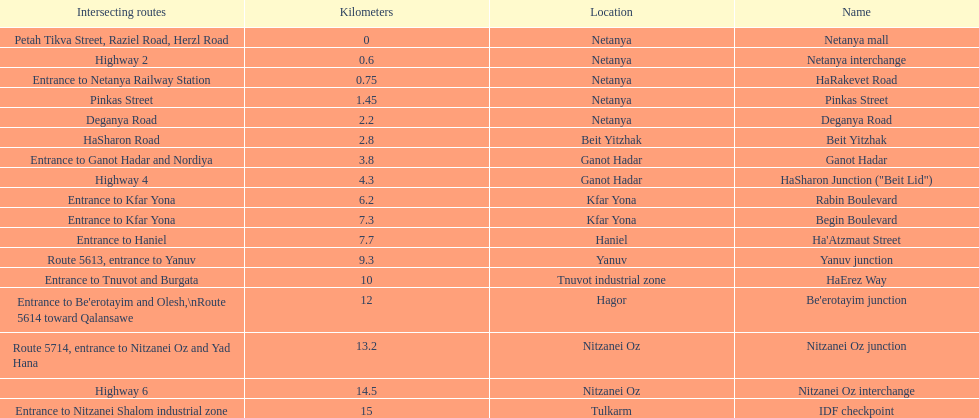Which portion has the same intersecting route as rabin boulevard? Begin Boulevard. Could you parse the entire table? {'header': ['Intersecting routes', 'Kilometers', 'Location', 'Name'], 'rows': [['Petah Tikva Street, Raziel Road, Herzl Road', '0', 'Netanya', 'Netanya mall'], ['Highway 2', '0.6', 'Netanya', 'Netanya interchange'], ['Entrance to Netanya Railway Station', '0.75', 'Netanya', 'HaRakevet Road'], ['Pinkas Street', '1.45', 'Netanya', 'Pinkas Street'], ['Deganya Road', '2.2', 'Netanya', 'Deganya Road'], ['HaSharon Road', '2.8', 'Beit Yitzhak', 'Beit Yitzhak'], ['Entrance to Ganot Hadar and Nordiya', '3.8', 'Ganot Hadar', 'Ganot Hadar'], ['Highway 4', '4.3', 'Ganot Hadar', 'HaSharon Junction ("Beit Lid")'], ['Entrance to Kfar Yona', '6.2', 'Kfar Yona', 'Rabin Boulevard'], ['Entrance to Kfar Yona', '7.3', 'Kfar Yona', 'Begin Boulevard'], ['Entrance to Haniel', '7.7', 'Haniel', "Ha'Atzmaut Street"], ['Route 5613, entrance to Yanuv', '9.3', 'Yanuv', 'Yanuv junction'], ['Entrance to Tnuvot and Burgata', '10', 'Tnuvot industrial zone', 'HaErez Way'], ["Entrance to Be'erotayim and Olesh,\\nRoute 5614 toward Qalansawe", '12', 'Hagor', "Be'erotayim junction"], ['Route 5714, entrance to Nitzanei Oz and Yad Hana', '13.2', 'Nitzanei Oz', 'Nitzanei Oz junction'], ['Highway 6', '14.5', 'Nitzanei Oz', 'Nitzanei Oz interchange'], ['Entrance to Nitzanei Shalom industrial zone', '15', 'Tulkarm', 'IDF checkpoint']]} 